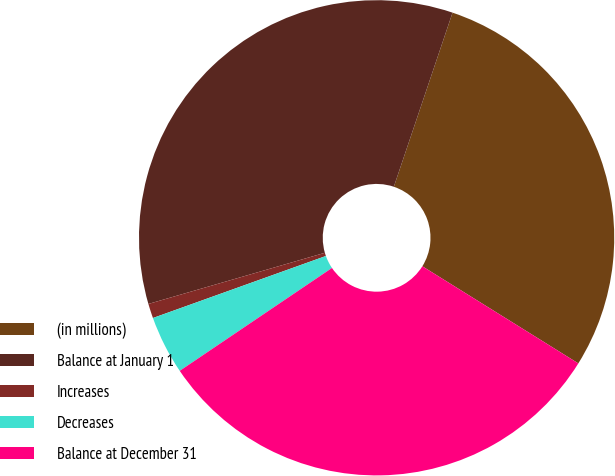<chart> <loc_0><loc_0><loc_500><loc_500><pie_chart><fcel>(in millions)<fcel>Balance at January 1<fcel>Increases<fcel>Decreases<fcel>Balance at December 31<nl><fcel>28.69%<fcel>34.67%<fcel>0.99%<fcel>3.98%<fcel>31.68%<nl></chart> 